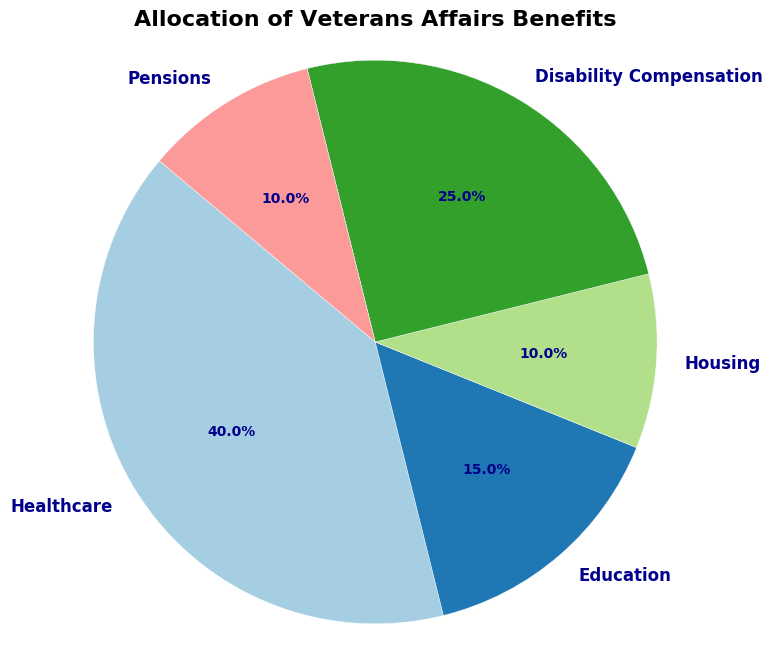Which category has the highest percentage in the allocation of Veterans Affairs benefits? The pie chart shows different categories with their respective percentages. By observing the figure, we can see that Healthcare has the largest portion, with the percentage visibly larger than the others.
Answer: Healthcare What is the total percentage allocated to Education and Housing? To find the total percentage for Education and Housing, we sum their individual percentages. Education is 15%, and Housing is 10%, so their combined total is 15% + 10%.
Answer: 25% Is the percentage allocated to Disability Compensation greater than the combined percentage of Housing and Pensions? First, observe the percentage for Disability Compensation, which is 25%. Then, sum the percentages of Housing (10%) and Pensions (10%), which is 10% + 10% = 20%. Comparing 25% and 20%, we see that 25% (for Disability Compensation) is indeed greater.
Answer: Yes Which two categories have an equal percentage allocation? By looking at the figure, we see that Housing and Pensions both have the same size slices and are labeled with the same percentage, 10%.
Answer: Housing and Pensions How much more percentage is allocated to Healthcare compared to Education? To find the difference between the percentages of Healthcare and Education, we subtract Education's percentage from Healthcare's. Healthcare has 40%, and Education has 15%, so the difference is 40% - 15%.
Answer: 25% What is the percentage difference between the highest and the lowest category? First, identify the highest percentage (Healthcare, 40%) and the lowest (Housing and Pensions, both at 10%). Then, calculate the difference: 40% - 10%.
Answer: 30% Combine the percentages of the top two categories. What is the total? The two highest categories are Healthcare (40%) and Disability Compensation (25%). Adding these gives us 40% + 25%.
Answer: 65% How is the pie chart color-coded? Which colors represent the top two categories? The chart uses different colors for each category. Visually identifying the wedges for Healthcare and Disability Compensation, we note that Healthcare is represented by a specific color and Disability Compensation by another distinct color. However, the specific colors vary depending on the visualization tool used, but typically they will be visually distinct.
Answer: The specific colors can be identified in the actual plot If the percentage for Housing were to increase by 5%, what would it be? Currently, Housing is given a 10% allocation. Adding 5% to this, 10% + 5% results in the new percentage for Housing.
Answer: 15% Compare the segment sizes for Education and Pensions. Are they different or the same? By observing the pie chart, it's clear that Education (15%) takes up a larger segment than Pensions (10%), indicating they are different sizes.
Answer: Different 